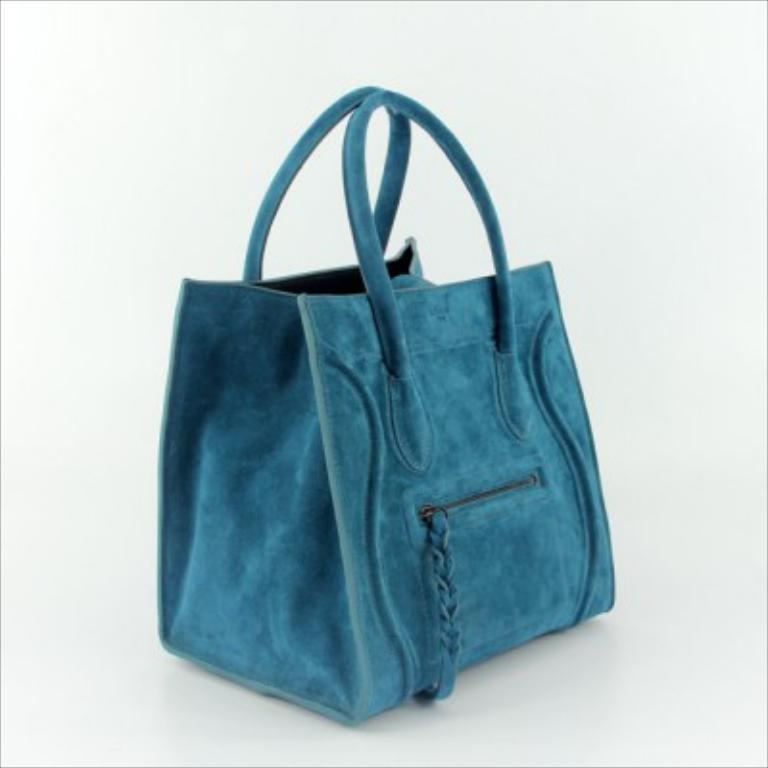What object can be seen in the image? There is a handbag in the image. What color is the handbag? The handbag is blue. What type of science experiment is being conducted with the handbag in the image? There is no science experiment or any reference to science in the image; it simply features a blue handbag. 